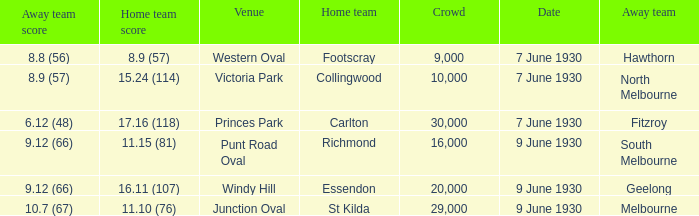Where did the away team score 8.9 (57)? Victoria Park. 